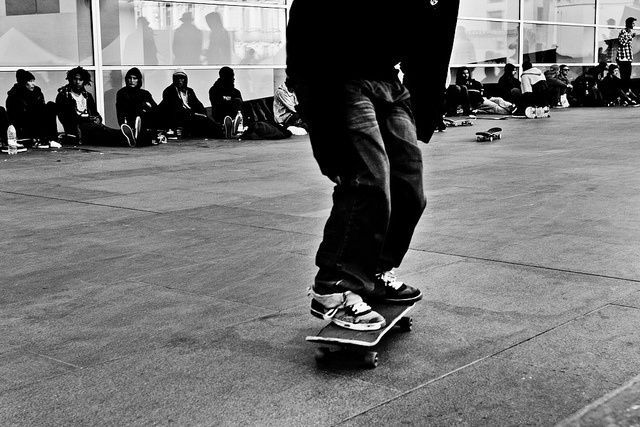Describe the objects in this image and their specific colors. I can see people in lightgray, black, gray, and darkgray tones, people in lightgray, black, gray, and darkgray tones, skateboard in lightgray, black, gray, and darkgray tones, people in lightgray, black, gray, and darkgray tones, and people in lightgray, black, gray, and darkgray tones in this image. 